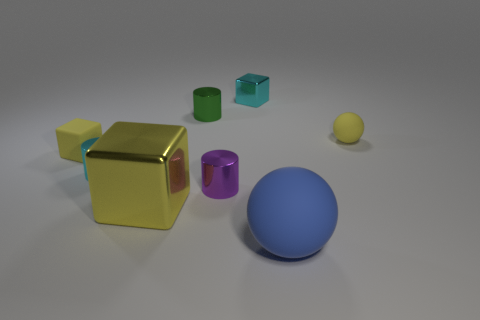Subtract all purple shiny cylinders. How many cylinders are left? 2 Subtract all purple cylinders. How many cylinders are left? 2 Subtract all cubes. How many objects are left? 5 Add 1 tiny cyan blocks. How many objects exist? 9 Subtract 1 spheres. How many spheres are left? 1 Subtract all cyan cylinders. Subtract all gray cubes. How many cylinders are left? 2 Subtract all cyan balls. How many purple cylinders are left? 1 Subtract all small brown metallic spheres. Subtract all tiny purple shiny cylinders. How many objects are left? 7 Add 5 small yellow balls. How many small yellow balls are left? 6 Add 1 small purple metallic cylinders. How many small purple metallic cylinders exist? 2 